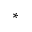<formula> <loc_0><loc_0><loc_500><loc_500>_ { * }</formula> 